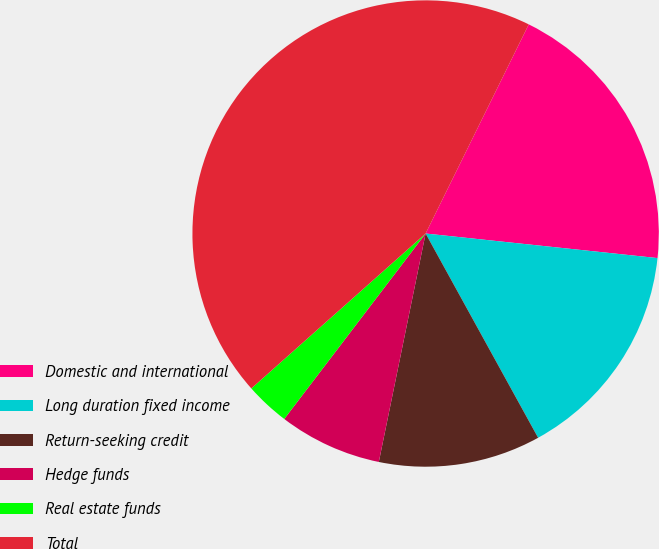<chart> <loc_0><loc_0><loc_500><loc_500><pie_chart><fcel>Domestic and international<fcel>Long duration fixed income<fcel>Return-seeking credit<fcel>Hedge funds<fcel>Real estate funds<fcel>Total<nl><fcel>19.39%<fcel>15.31%<fcel>11.23%<fcel>7.15%<fcel>3.07%<fcel>43.86%<nl></chart> 